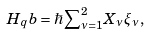<formula> <loc_0><loc_0><loc_500><loc_500>H _ { q } b = \hbar { \sum } _ { \nu = 1 } ^ { 2 } X _ { \nu } \xi _ { \nu } \, ,</formula> 